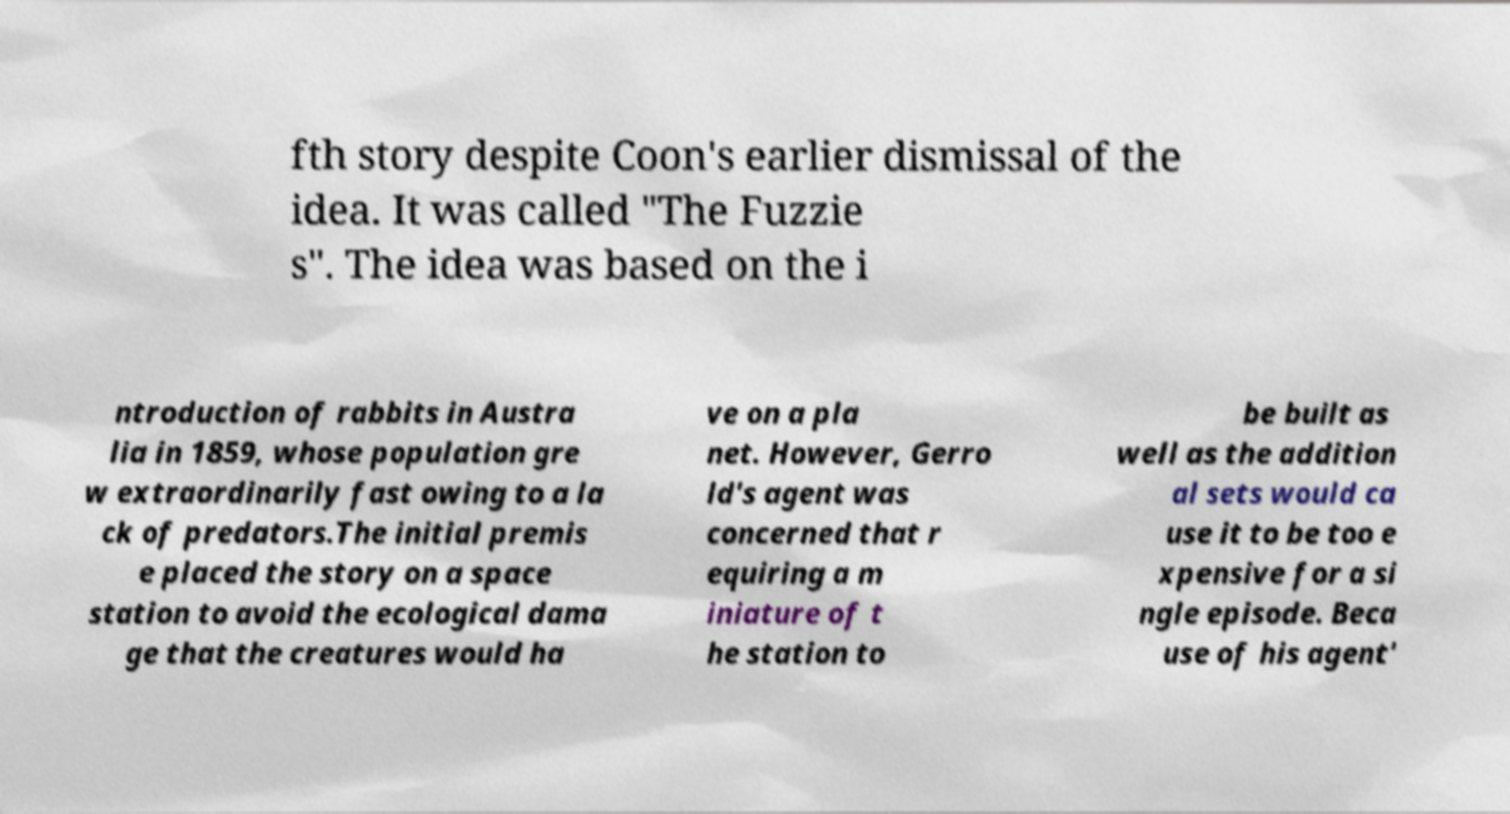Could you assist in decoding the text presented in this image and type it out clearly? fth story despite Coon's earlier dismissal of the idea. It was called "The Fuzzie s". The idea was based on the i ntroduction of rabbits in Austra lia in 1859, whose population gre w extraordinarily fast owing to a la ck of predators.The initial premis e placed the story on a space station to avoid the ecological dama ge that the creatures would ha ve on a pla net. However, Gerro ld's agent was concerned that r equiring a m iniature of t he station to be built as well as the addition al sets would ca use it to be too e xpensive for a si ngle episode. Beca use of his agent' 